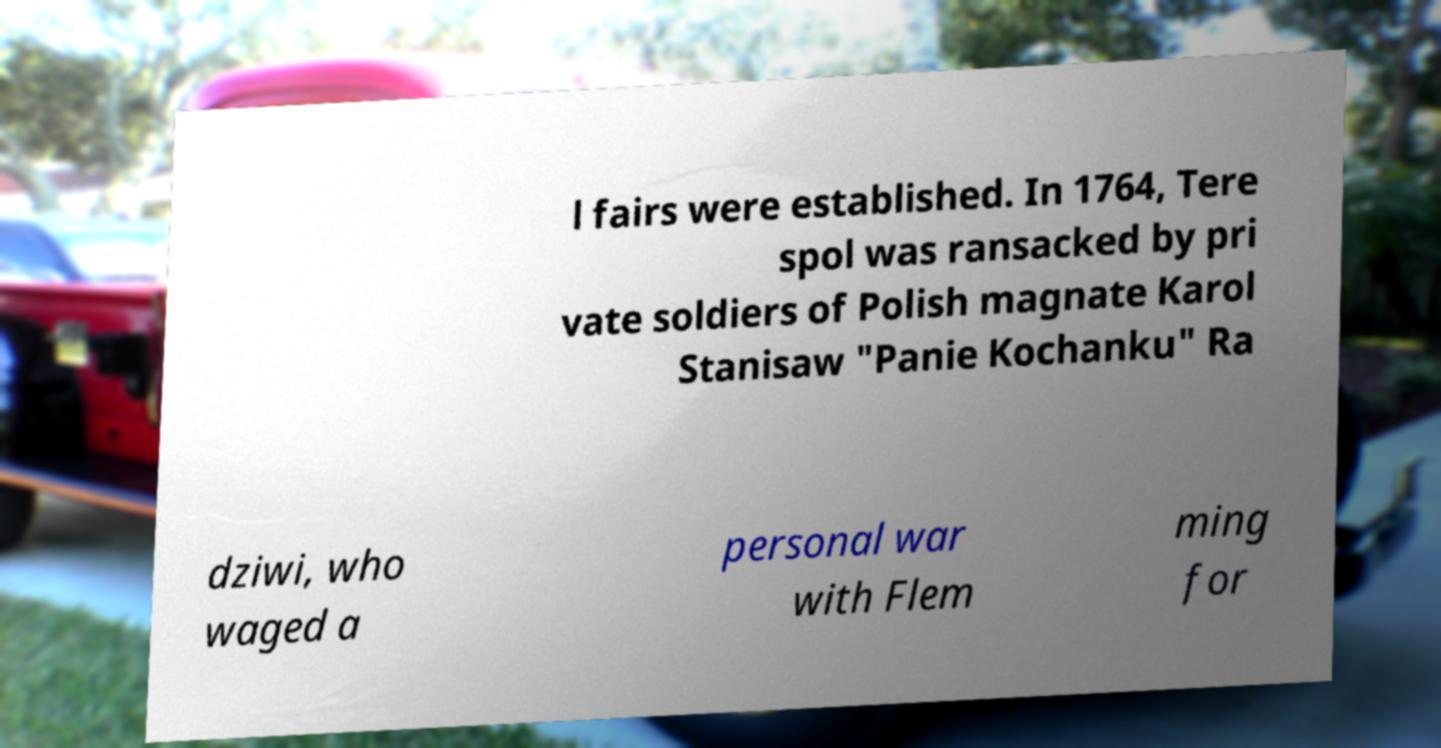Could you extract and type out the text from this image? l fairs were established. In 1764, Tere spol was ransacked by pri vate soldiers of Polish magnate Karol Stanisaw "Panie Kochanku" Ra dziwi, who waged a personal war with Flem ming for 